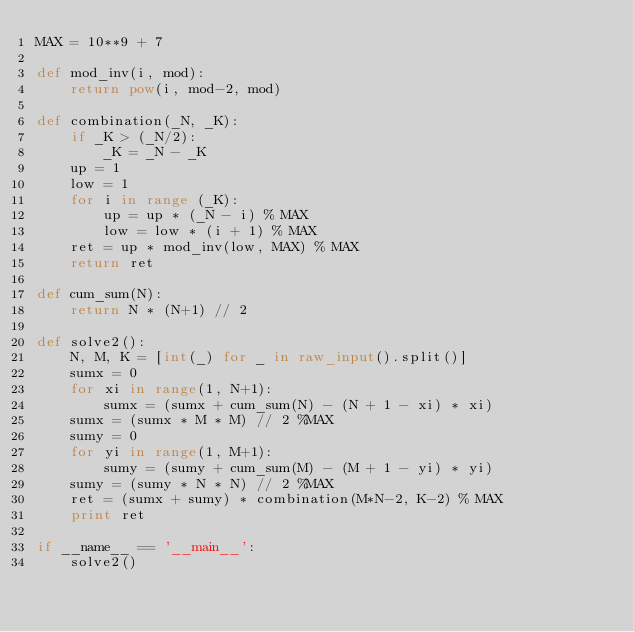Convert code to text. <code><loc_0><loc_0><loc_500><loc_500><_Python_>MAX = 10**9 + 7

def mod_inv(i, mod):
    return pow(i, mod-2, mod)

def combination(_N, _K):
    if _K > (_N/2):
        _K = _N - _K
    up = 1
    low = 1
    for i in range (_K):
        up = up * (_N - i) % MAX
        low = low * (i + 1) % MAX
    ret = up * mod_inv(low, MAX) % MAX
    return ret

def cum_sum(N):
    return N * (N+1) // 2

def solve2():
    N, M, K = [int(_) for _ in raw_input().split()]
    sumx = 0
    for xi in range(1, N+1):
        sumx = (sumx + cum_sum(N) - (N + 1 - xi) * xi)
    sumx = (sumx * M * M) // 2 %MAX
    sumy = 0
    for yi in range(1, M+1):
        sumy = (sumy + cum_sum(M) - (M + 1 - yi) * yi)
    sumy = (sumy * N * N) // 2 %MAX
    ret = (sumx + sumy) * combination(M*N-2, K-2) % MAX
    print ret

if __name__ == '__main__':
    solve2()
</code> 